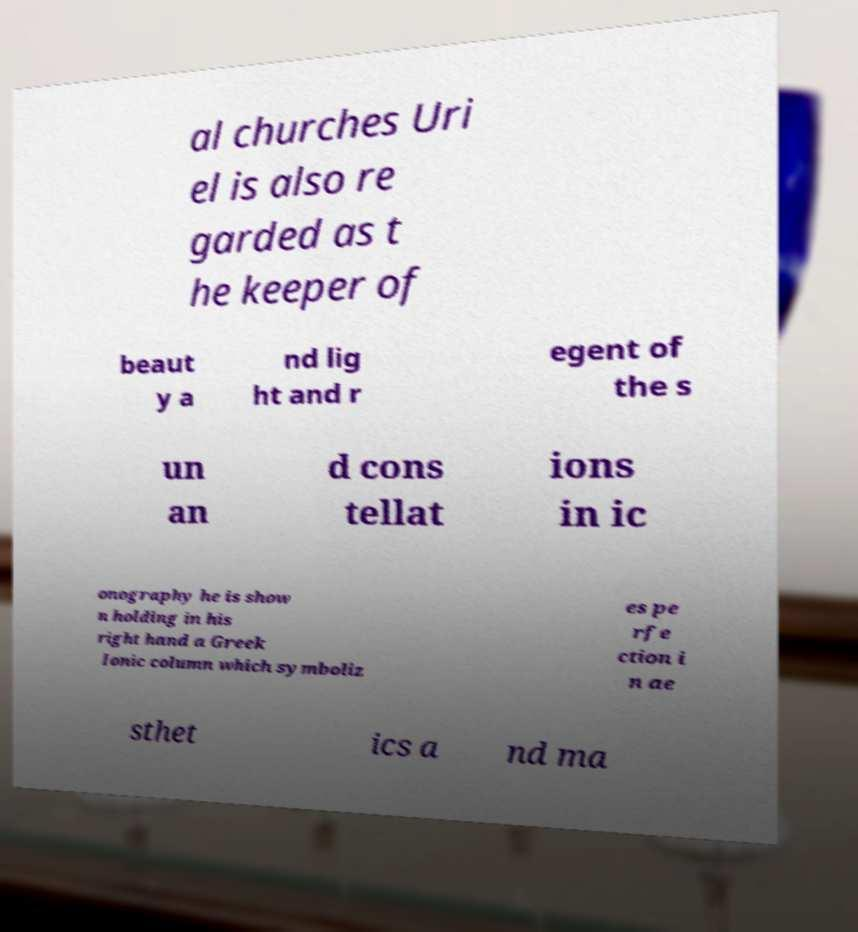For documentation purposes, I need the text within this image transcribed. Could you provide that? al churches Uri el is also re garded as t he keeper of beaut y a nd lig ht and r egent of the s un an d cons tellat ions in ic onography he is show n holding in his right hand a Greek Ionic column which symboliz es pe rfe ction i n ae sthet ics a nd ma 